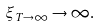<formula> <loc_0><loc_0><loc_500><loc_500>\xi _ { T \to \infty } \to \infty .</formula> 